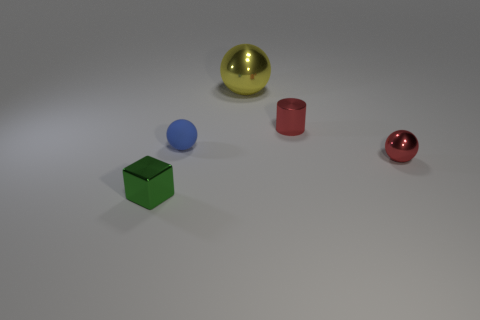Subtract all metallic balls. How many balls are left? 1 Add 3 tiny blue rubber objects. How many objects exist? 8 Subtract 2 balls. How many balls are left? 1 Subtract all cubes. How many objects are left? 4 Subtract all yellow balls. How many balls are left? 2 Subtract 0 blue blocks. How many objects are left? 5 Subtract all gray cubes. Subtract all green cylinders. How many cubes are left? 1 Subtract all tiny spheres. Subtract all blue metallic cubes. How many objects are left? 3 Add 4 tiny metallic cylinders. How many tiny metallic cylinders are left? 5 Add 3 matte cubes. How many matte cubes exist? 3 